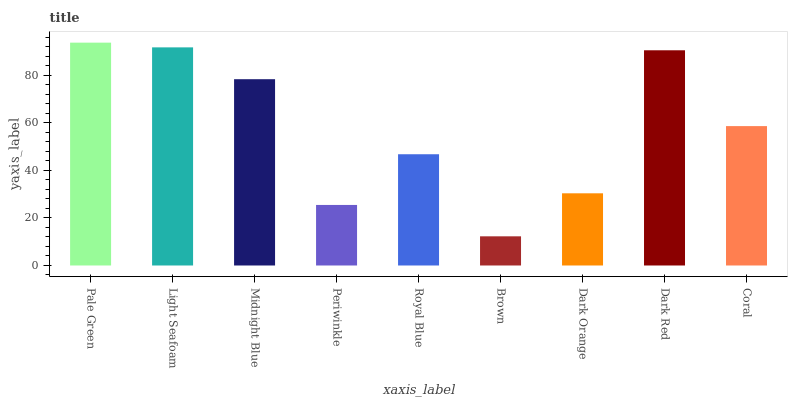Is Brown the minimum?
Answer yes or no. Yes. Is Pale Green the maximum?
Answer yes or no. Yes. Is Light Seafoam the minimum?
Answer yes or no. No. Is Light Seafoam the maximum?
Answer yes or no. No. Is Pale Green greater than Light Seafoam?
Answer yes or no. Yes. Is Light Seafoam less than Pale Green?
Answer yes or no. Yes. Is Light Seafoam greater than Pale Green?
Answer yes or no. No. Is Pale Green less than Light Seafoam?
Answer yes or no. No. Is Coral the high median?
Answer yes or no. Yes. Is Coral the low median?
Answer yes or no. Yes. Is Dark Red the high median?
Answer yes or no. No. Is Periwinkle the low median?
Answer yes or no. No. 